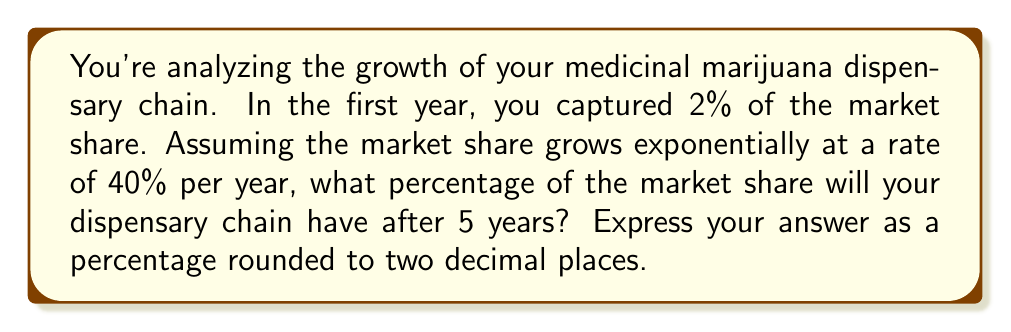Provide a solution to this math problem. To solve this problem, we'll use the exponential growth formula:

$$A = P(1 + r)^t$$

Where:
$A$ = Final amount
$P$ = Initial amount (principal)
$r$ = Growth rate (as a decimal)
$t$ = Time period

Given:
$P = 2\%$ (initial market share)
$r = 40\% = 0.40$ (growth rate)
$t = 5$ years

Let's plug these values into the formula:

$$A = 2\%(1 + 0.40)^5$$

Now, let's calculate step-by-step:

1) First, calculate $(1 + 0.40)^5$:
   $$(1.40)^5 = 5.3780$$

2) Multiply this by the initial market share:
   $$2\% \times 5.3780 = 0.02 \times 5.3780 = 0.10756$$

3) Convert to a percentage:
   $$0.10756 \times 100\% = 10.756\%$$

4) Round to two decimal places:
   $$10.76\%$$
Answer: 10.76% 